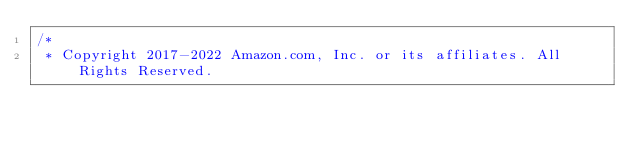<code> <loc_0><loc_0><loc_500><loc_500><_Java_>/*
 * Copyright 2017-2022 Amazon.com, Inc. or its affiliates. All Rights Reserved.</code> 